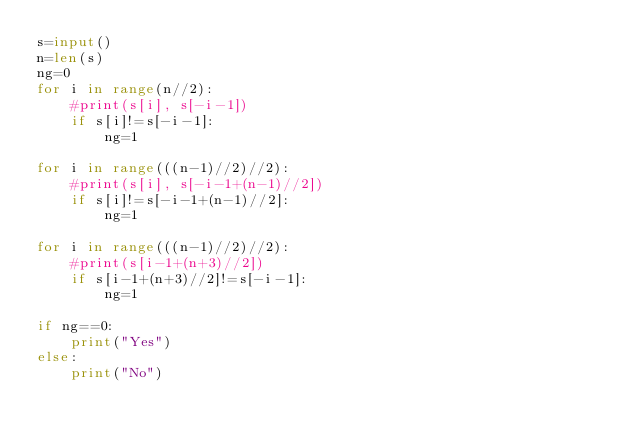<code> <loc_0><loc_0><loc_500><loc_500><_Python_>s=input()
n=len(s)
ng=0
for i in range(n//2):
    #print(s[i], s[-i-1])
    if s[i]!=s[-i-1]:
        ng=1

for i in range(((n-1)//2)//2):
    #print(s[i], s[-i-1+(n-1)//2])
    if s[i]!=s[-i-1+(n-1)//2]:
        ng=1

for i in range(((n-1)//2)//2):
    #print(s[i-1+(n+3)//2])
    if s[i-1+(n+3)//2]!=s[-i-1]:
        ng=1

if ng==0:
    print("Yes")
else:
    print("No")</code> 